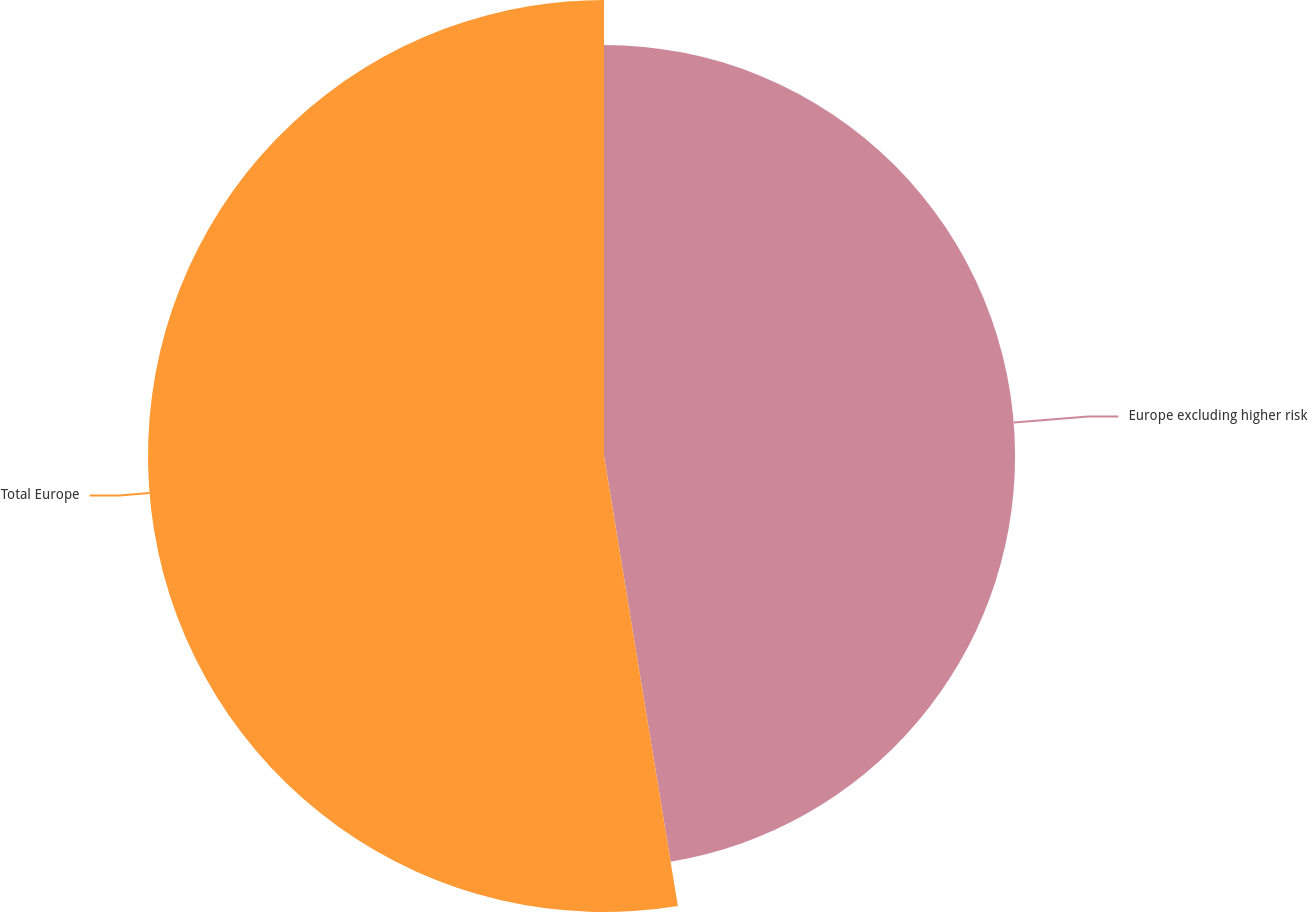Convert chart to OTSL. <chart><loc_0><loc_0><loc_500><loc_500><pie_chart><fcel>Europe excluding higher risk<fcel>Total Europe<nl><fcel>47.41%<fcel>52.59%<nl></chart> 